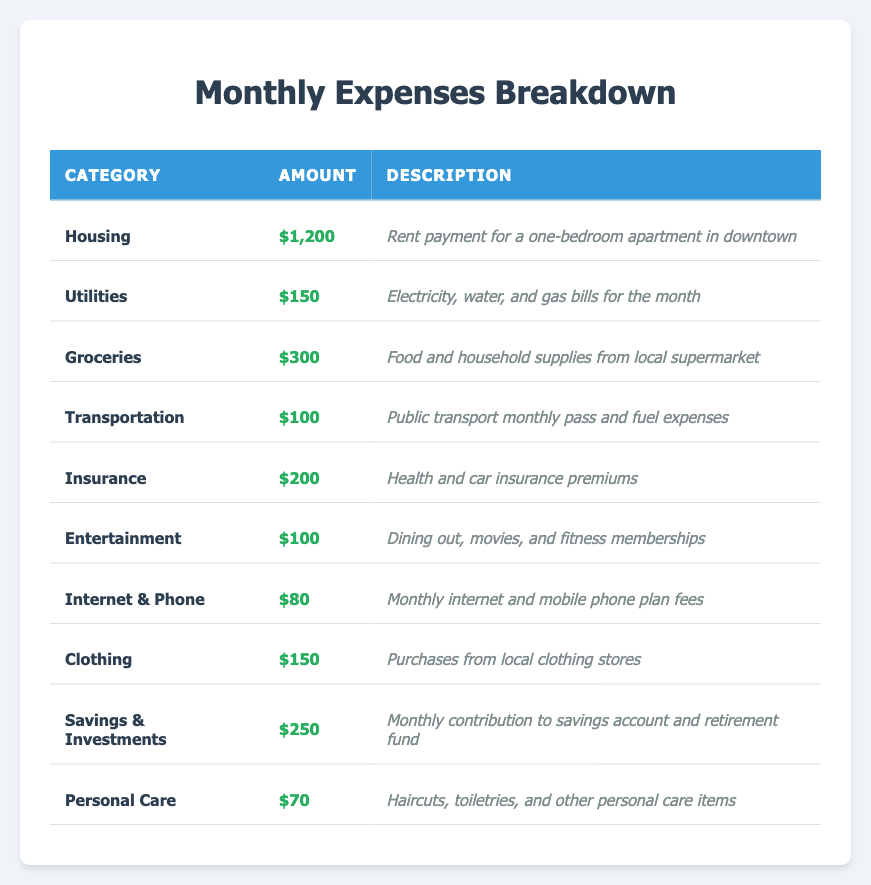What is the total amount spent on Groceries and Transportation? To find the total amount spent on Groceries and Transportation, we first find the amounts: Groceries = $300 and Transportation = $100. Then we sum these amounts: $300 + $100 = $400.
Answer: $400 What category has the highest expense? By reviewing the table, we see that the Housing category has the highest amount at $1,200.
Answer: Housing What is the sum of all expenses listed in the table? We add all the amounts in each category: $1,200 (Housing) + $150 (Utilities) + $300 (Groceries) + $100 (Transportation) + $200 (Insurance) + $100 (Entertainment) + $80 (Internet & Phone) + $150 (Clothing) + $250 (Savings & Investments) + $70 (Personal Care) = $2,700.
Answer: $2,700 Is the expense on Internet & Phone greater than that on Personal Care? The table shows that Internet & Phone costs $80 and Personal Care costs $70. Since $80 is greater than $70, the statement is true.
Answer: Yes What is the average expense across all categories? To find the average, we first calculate the total expenses, which is $2,700 (from the previous answer). There are 10 categories, so we divide the total by the number of categories: $2,700 / 10 = $270.
Answer: $270 Which two categories combined have an expense close to $1,000? According to the table, we check various combinations. The combination of Housing ($1,200) stands alone, but the combination of Savings & Investments ($250) and Groceries ($300) totals $550. No two categories combine to approach $1,000 closely. However, Housing is close to this number alone. Therefore, no combination of total expenses closely matches $1,000.
Answer: No combination closely matches $1,000 What percentage of the total expenses does Transportation represent? Transportation amounts to $100, and the total expenses are $2,700. To find the percentage, we calculate: ($100 / $2,700) * 100 = approximately 3.7%.
Answer: 3.7% Which category spends less than $150? The categories with expenses less than $150 are Utilities ($150), Transportation ($100), Internet & Phone ($80), Personal Care ($70), and Entertainment ($100). Therefore, Utilities does not qualify, but the others do.
Answer: Transportation, Internet & Phone, Personal Care, Entertainment How much more is spent on Housing compared to Personal Care? In the table, Housing costs $1,200 and Personal Care costs $70. To find the difference, we subtract: $1,200 - $70 = $1,130.
Answer: $1,130 Are there any expenses listed that are equal to $100? By checking the table, we see that both Transportation and Entertainment have amounts equal to $100. Therefore, the answer is yes.
Answer: Yes 